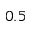Convert formula to latex. <formula><loc_0><loc_0><loc_500><loc_500>0 . 5</formula> 